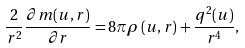<formula> <loc_0><loc_0><loc_500><loc_500>\frac { 2 } { r ^ { 2 } } \frac { \partial m ( u , r ) } { \partial r } = 8 \pi \rho \left ( u , r \right ) + \frac { q ^ { 2 } ( u ) } { r ^ { 4 } } ,</formula> 